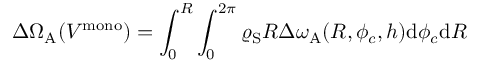<formula> <loc_0><loc_0><loc_500><loc_500>\Delta \Omega _ { A } ( V ^ { m o n o } ) = \int _ { 0 } ^ { R } \int _ { 0 } ^ { 2 \pi } \varrho _ { S } R \Delta \omega _ { A } ( R , \phi _ { c } , h ) d \phi _ { c } d R</formula> 